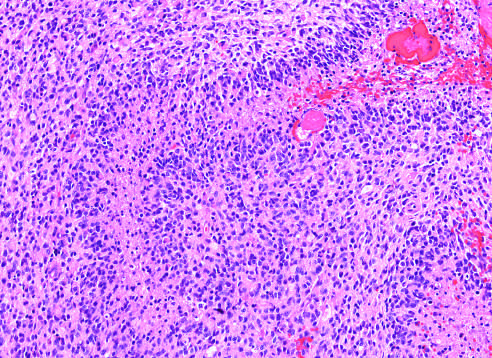s the wall of the aneurysm a densely cellular tumor with necrosis and pseudo-palisading of tumor cell nuclei along the edge of the necrotic zone?
Answer the question using a single word or phrase. No 